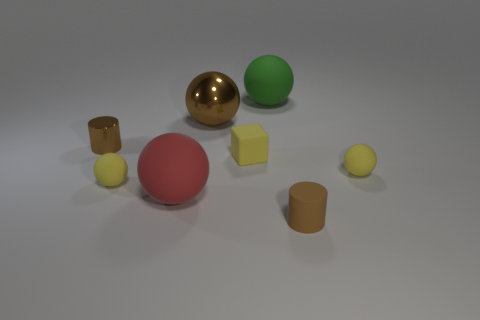Subtract all red rubber spheres. How many spheres are left? 4 Subtract all green blocks. How many yellow spheres are left? 2 Add 1 brown objects. How many objects exist? 9 Subtract all brown spheres. How many spheres are left? 4 Subtract 3 spheres. How many spheres are left? 2 Subtract all blocks. How many objects are left? 7 Subtract all green spheres. Subtract all gray cylinders. How many spheres are left? 4 Add 3 green things. How many green things are left? 4 Add 6 small yellow balls. How many small yellow balls exist? 8 Subtract 0 red cylinders. How many objects are left? 8 